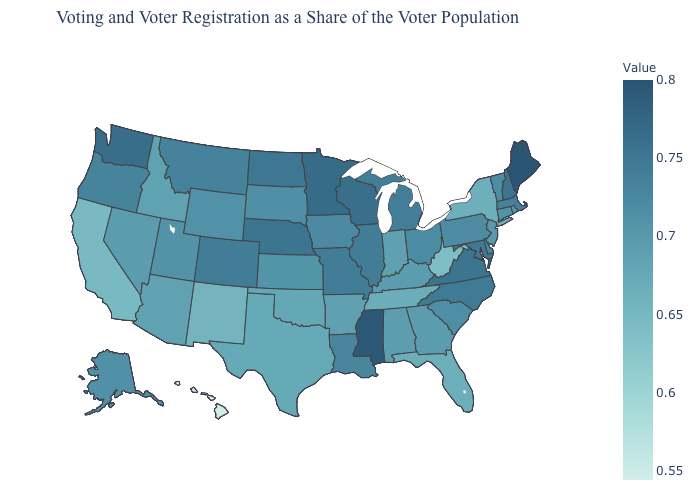Does Montana have the highest value in the West?
Quick response, please. No. Which states have the lowest value in the MidWest?
Quick response, please. Indiana. Is the legend a continuous bar?
Answer briefly. Yes. Among the states that border Utah , does New Mexico have the lowest value?
Short answer required. Yes. Does Arkansas have a lower value than West Virginia?
Be succinct. No. Which states hav the highest value in the Northeast?
Short answer required. Maine. 